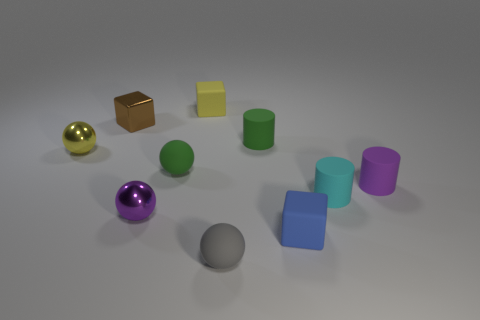Does the metallic sphere that is behind the cyan object have the same size as the tiny yellow matte cube?
Keep it short and to the point. Yes. What number of tiny rubber things are both on the right side of the tiny green cylinder and in front of the small purple metal ball?
Offer a very short reply. 1. There is a green object to the right of the tiny green rubber thing that is on the left side of the tiny green cylinder; what size is it?
Give a very brief answer. Small. Is the number of green matte cylinders that are to the left of the tiny yellow shiny object less than the number of small yellow metallic spheres in front of the small gray matte ball?
Make the answer very short. No. Is the color of the tiny rubber cube to the left of the small gray thing the same as the matte cube in front of the small yellow block?
Your response must be concise. No. There is a small thing that is left of the tiny blue matte object and right of the tiny gray rubber thing; what is its material?
Provide a succinct answer. Rubber. Is there a purple metal object?
Your answer should be very brief. Yes. What is the shape of the small cyan thing that is the same material as the tiny purple cylinder?
Give a very brief answer. Cylinder. There is a tiny gray object; does it have the same shape as the shiny object that is in front of the yellow metal object?
Make the answer very short. Yes. What material is the tiny cylinder behind the rubber cylinder that is on the right side of the tiny cyan thing made of?
Your answer should be compact. Rubber. 